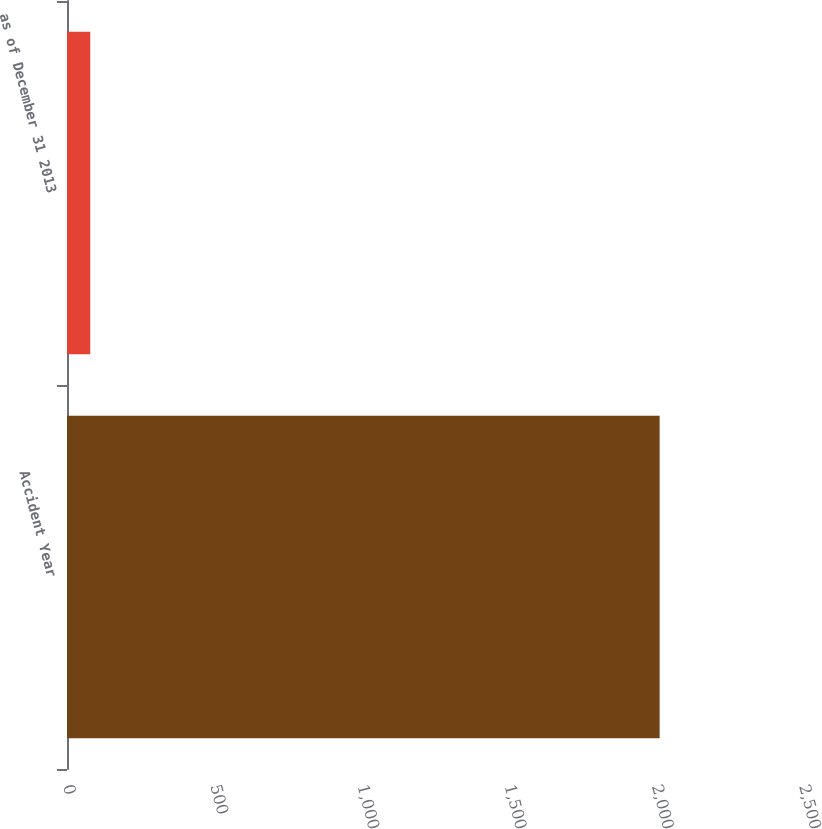Convert chart to OTSL. <chart><loc_0><loc_0><loc_500><loc_500><bar_chart><fcel>Accident Year<fcel>as of December 31 2013<nl><fcel>2013<fcel>79<nl></chart> 